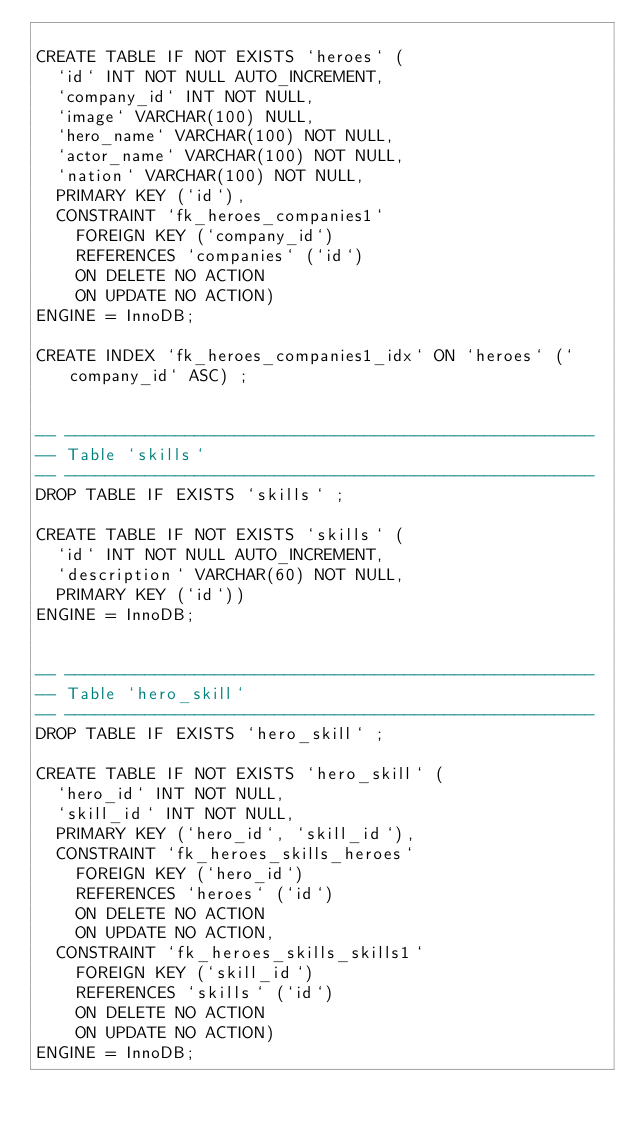<code> <loc_0><loc_0><loc_500><loc_500><_SQL_>
CREATE TABLE IF NOT EXISTS `heroes` (
  `id` INT NOT NULL AUTO_INCREMENT,
  `company_id` INT NOT NULL,
  `image` VARCHAR(100) NULL,
  `hero_name` VARCHAR(100) NOT NULL,
  `actor_name` VARCHAR(100) NOT NULL,
  `nation` VARCHAR(100) NOT NULL,
  PRIMARY KEY (`id`),
  CONSTRAINT `fk_heroes_companies1`
    FOREIGN KEY (`company_id`)
    REFERENCES `companies` (`id`)
    ON DELETE NO ACTION
    ON UPDATE NO ACTION)
ENGINE = InnoDB;

CREATE INDEX `fk_heroes_companies1_idx` ON `heroes` (`company_id` ASC) ;


-- -----------------------------------------------------
-- Table `skills`
-- -----------------------------------------------------
DROP TABLE IF EXISTS `skills` ;

CREATE TABLE IF NOT EXISTS `skills` (
  `id` INT NOT NULL AUTO_INCREMENT,
  `description` VARCHAR(60) NOT NULL,
  PRIMARY KEY (`id`))
ENGINE = InnoDB;


-- -----------------------------------------------------
-- Table `hero_skill`
-- -----------------------------------------------------
DROP TABLE IF EXISTS `hero_skill` ;

CREATE TABLE IF NOT EXISTS `hero_skill` (
  `hero_id` INT NOT NULL,
  `skill_id` INT NOT NULL,
  PRIMARY KEY (`hero_id`, `skill_id`),
  CONSTRAINT `fk_heroes_skills_heroes`
    FOREIGN KEY (`hero_id`)
    REFERENCES `heroes` (`id`)
    ON DELETE NO ACTION
    ON UPDATE NO ACTION,
  CONSTRAINT `fk_heroes_skills_skills1`
    FOREIGN KEY (`skill_id`)
    REFERENCES `skills` (`id`)
    ON DELETE NO ACTION
    ON UPDATE NO ACTION)
ENGINE = InnoDB;
</code> 